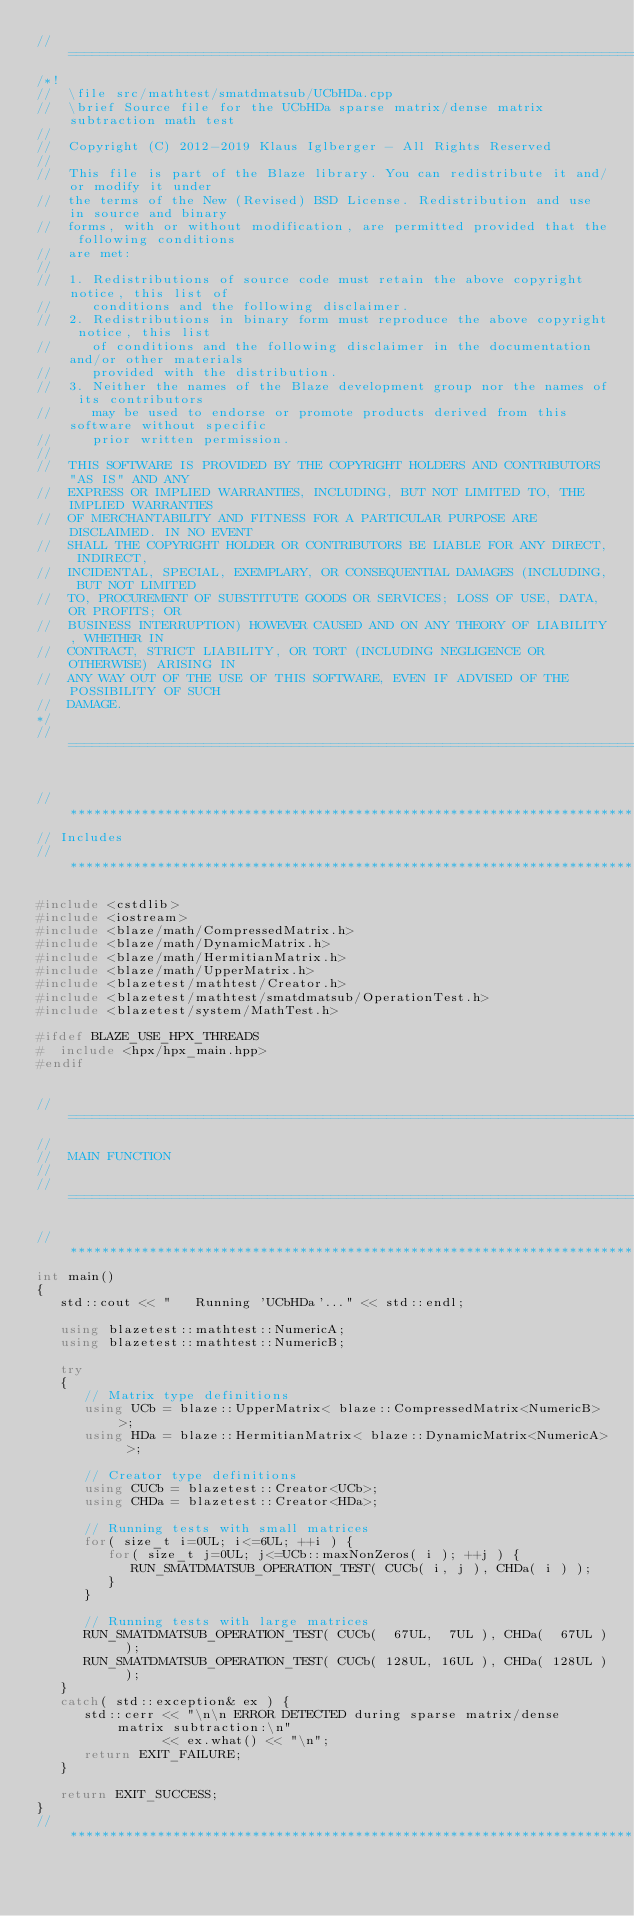Convert code to text. <code><loc_0><loc_0><loc_500><loc_500><_C++_>//=================================================================================================
/*!
//  \file src/mathtest/smatdmatsub/UCbHDa.cpp
//  \brief Source file for the UCbHDa sparse matrix/dense matrix subtraction math test
//
//  Copyright (C) 2012-2019 Klaus Iglberger - All Rights Reserved
//
//  This file is part of the Blaze library. You can redistribute it and/or modify it under
//  the terms of the New (Revised) BSD License. Redistribution and use in source and binary
//  forms, with or without modification, are permitted provided that the following conditions
//  are met:
//
//  1. Redistributions of source code must retain the above copyright notice, this list of
//     conditions and the following disclaimer.
//  2. Redistributions in binary form must reproduce the above copyright notice, this list
//     of conditions and the following disclaimer in the documentation and/or other materials
//     provided with the distribution.
//  3. Neither the names of the Blaze development group nor the names of its contributors
//     may be used to endorse or promote products derived from this software without specific
//     prior written permission.
//
//  THIS SOFTWARE IS PROVIDED BY THE COPYRIGHT HOLDERS AND CONTRIBUTORS "AS IS" AND ANY
//  EXPRESS OR IMPLIED WARRANTIES, INCLUDING, BUT NOT LIMITED TO, THE IMPLIED WARRANTIES
//  OF MERCHANTABILITY AND FITNESS FOR A PARTICULAR PURPOSE ARE DISCLAIMED. IN NO EVENT
//  SHALL THE COPYRIGHT HOLDER OR CONTRIBUTORS BE LIABLE FOR ANY DIRECT, INDIRECT,
//  INCIDENTAL, SPECIAL, EXEMPLARY, OR CONSEQUENTIAL DAMAGES (INCLUDING, BUT NOT LIMITED
//  TO, PROCUREMENT OF SUBSTITUTE GOODS OR SERVICES; LOSS OF USE, DATA, OR PROFITS; OR
//  BUSINESS INTERRUPTION) HOWEVER CAUSED AND ON ANY THEORY OF LIABILITY, WHETHER IN
//  CONTRACT, STRICT LIABILITY, OR TORT (INCLUDING NEGLIGENCE OR OTHERWISE) ARISING IN
//  ANY WAY OUT OF THE USE OF THIS SOFTWARE, EVEN IF ADVISED OF THE POSSIBILITY OF SUCH
//  DAMAGE.
*/
//=================================================================================================


//*************************************************************************************************
// Includes
//*************************************************************************************************

#include <cstdlib>
#include <iostream>
#include <blaze/math/CompressedMatrix.h>
#include <blaze/math/DynamicMatrix.h>
#include <blaze/math/HermitianMatrix.h>
#include <blaze/math/UpperMatrix.h>
#include <blazetest/mathtest/Creator.h>
#include <blazetest/mathtest/smatdmatsub/OperationTest.h>
#include <blazetest/system/MathTest.h>

#ifdef BLAZE_USE_HPX_THREADS
#  include <hpx/hpx_main.hpp>
#endif


//=================================================================================================
//
//  MAIN FUNCTION
//
//=================================================================================================

//*************************************************************************************************
int main()
{
   std::cout << "   Running 'UCbHDa'..." << std::endl;

   using blazetest::mathtest::NumericA;
   using blazetest::mathtest::NumericB;

   try
   {
      // Matrix type definitions
      using UCb = blaze::UpperMatrix< blaze::CompressedMatrix<NumericB> >;
      using HDa = blaze::HermitianMatrix< blaze::DynamicMatrix<NumericA> >;

      // Creator type definitions
      using CUCb = blazetest::Creator<UCb>;
      using CHDa = blazetest::Creator<HDa>;

      // Running tests with small matrices
      for( size_t i=0UL; i<=6UL; ++i ) {
         for( size_t j=0UL; j<=UCb::maxNonZeros( i ); ++j ) {
            RUN_SMATDMATSUB_OPERATION_TEST( CUCb( i, j ), CHDa( i ) );
         }
      }

      // Running tests with large matrices
      RUN_SMATDMATSUB_OPERATION_TEST( CUCb(  67UL,  7UL ), CHDa(  67UL ) );
      RUN_SMATDMATSUB_OPERATION_TEST( CUCb( 128UL, 16UL ), CHDa( 128UL ) );
   }
   catch( std::exception& ex ) {
      std::cerr << "\n\n ERROR DETECTED during sparse matrix/dense matrix subtraction:\n"
                << ex.what() << "\n";
      return EXIT_FAILURE;
   }

   return EXIT_SUCCESS;
}
//*************************************************************************************************
</code> 